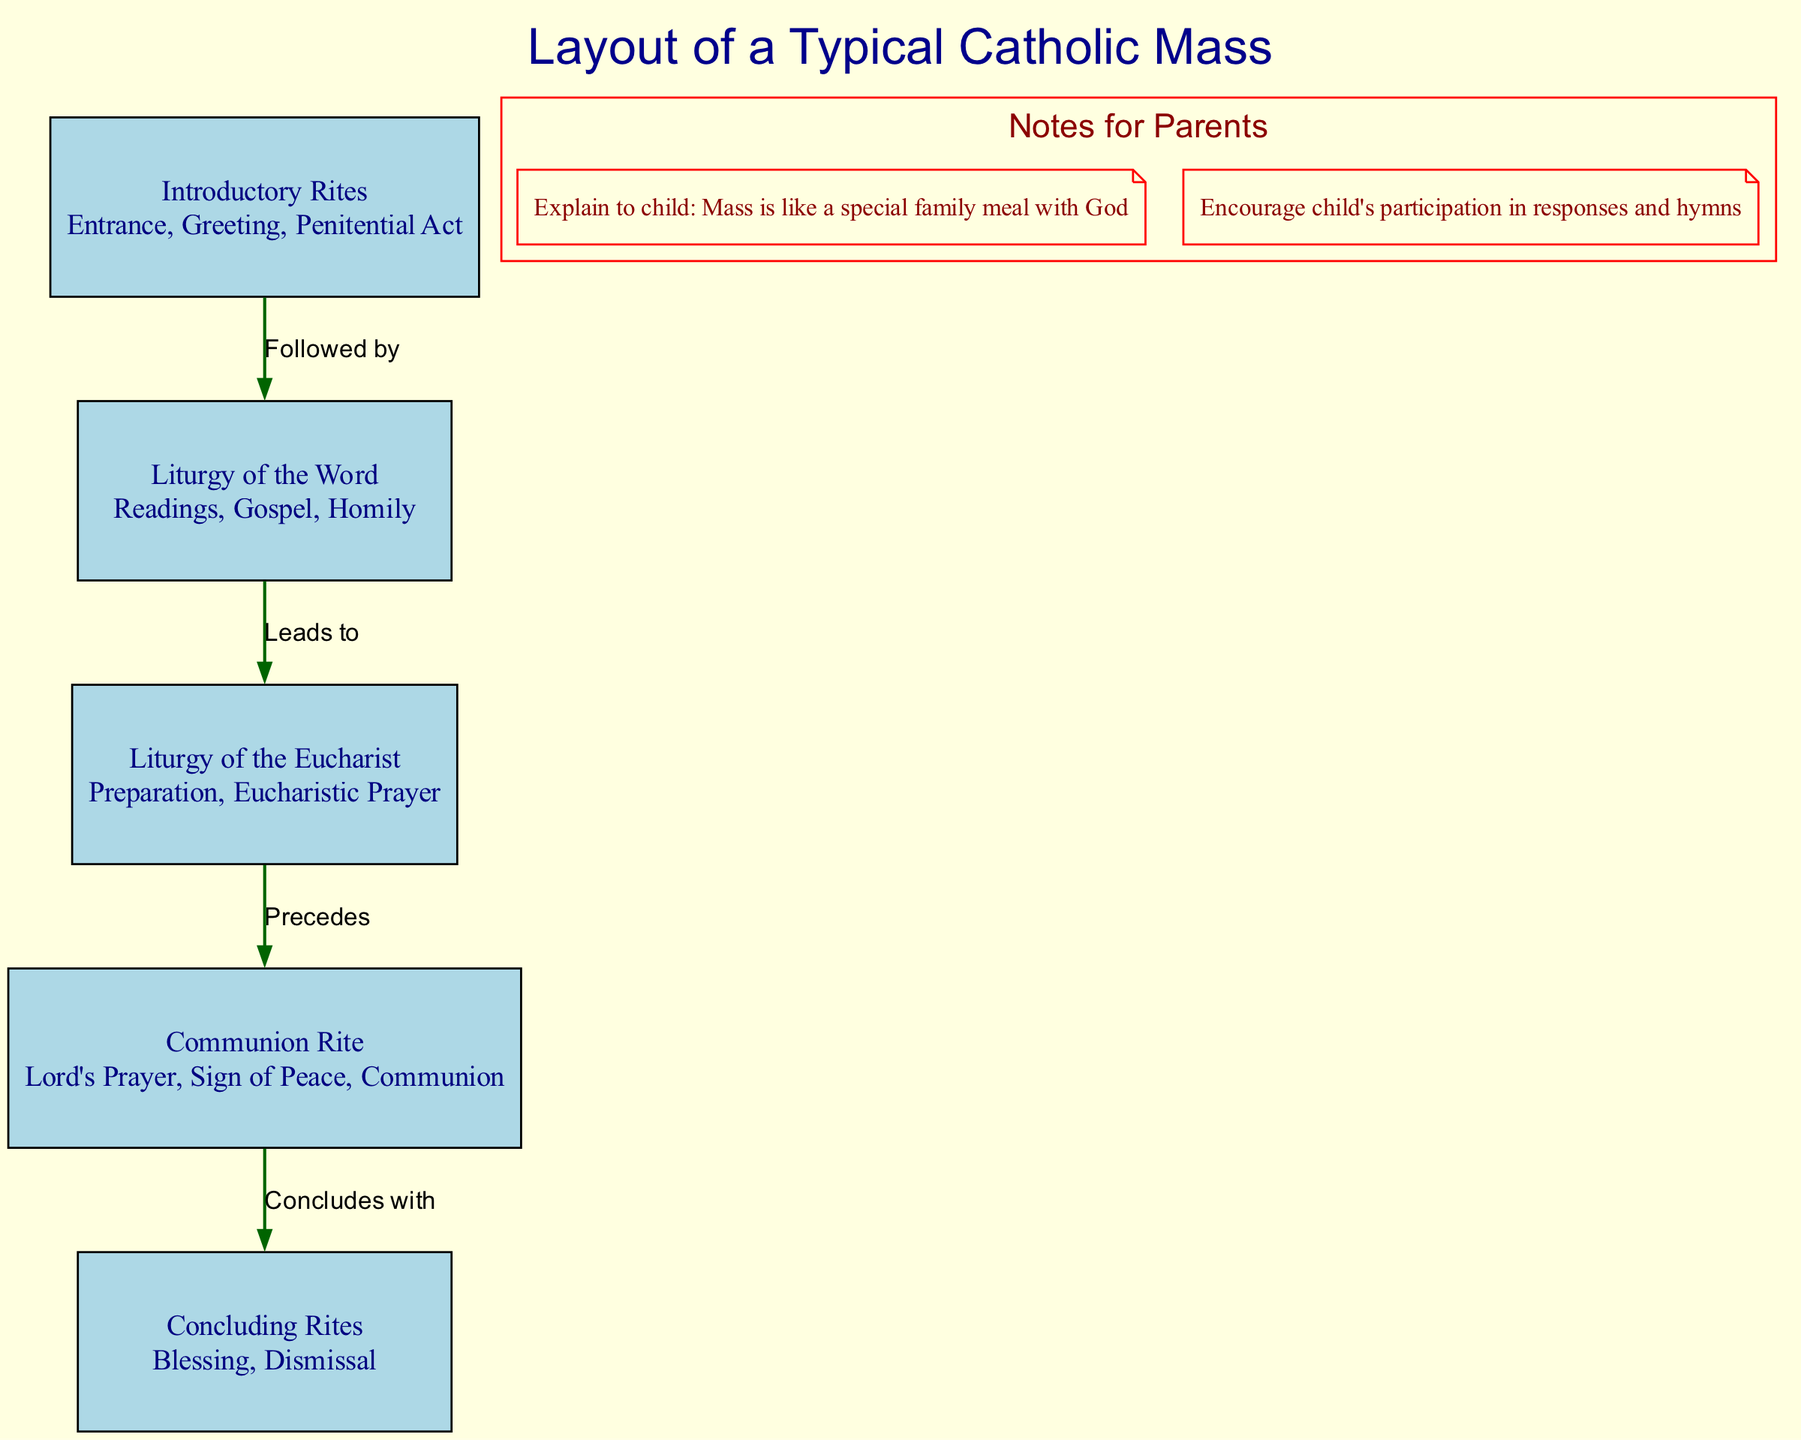What is the first element of the Mass? The first element is "Introductory Rites," which includes the Entrance, Greeting, and Penitential Act according to the diagram.
Answer: Introductory Rites How many main elements are there in the Mass? The diagram lists five main elements of the Mass: Introductory Rites, Liturgy of the Word, Liturgy of the Eucharist, Communion Rite, and Concluding Rites.
Answer: Five What does the Liturgy of the Word lead to? According to the diagram, the Liturgy of the Word leads to the Liturgy of the Eucharist, indicating the order of the elements in the Mass.
Answer: Liturgy of the Eucharist What is included in the Communion Rite? The Communion Rite includes the Lord's Prayer, Sign of Peace, and Communion, as described in the diagram.
Answer: Lord's Prayer, Sign of Peace, Communion What does the Liturgy of the Eucharist precede? The diagram shows that the Liturgy of the Eucharist precedes the Communion Rite, which identifies the flow of the Mass elements.
Answer: Communion Rite Which element concludes with the Blessing? The Concluding Rites conclude the Mass with the Blessing, as indicated in the diagram's flow of the Mass.
Answer: Concluding Rites What color is used for the edges in the diagram? The edges in the diagram are colored dark green, which visually connects the elements of the Mass in the diagram.
Answer: Dark green Explain the relationship between the Introductory Rites and the Liturgy of the Word. The diagram indicates that the Introductory Rites are followed by the Liturgy of the Word, suggesting a sequential flow from the opening of the Mass into the scripture readings and homily.
Answer: Followed by What are the notes intended for? The notes for parents in the diagram provide guidance on explaining the Mass to children and encouraging participation.
Answer: Parents What is the significance of the diagram's color scheme? The light yellow background and other color choices distinguish different elements and highlight the flow of the Mass, making it visually engaging and easy to follow.
Answer: Visual engagement 